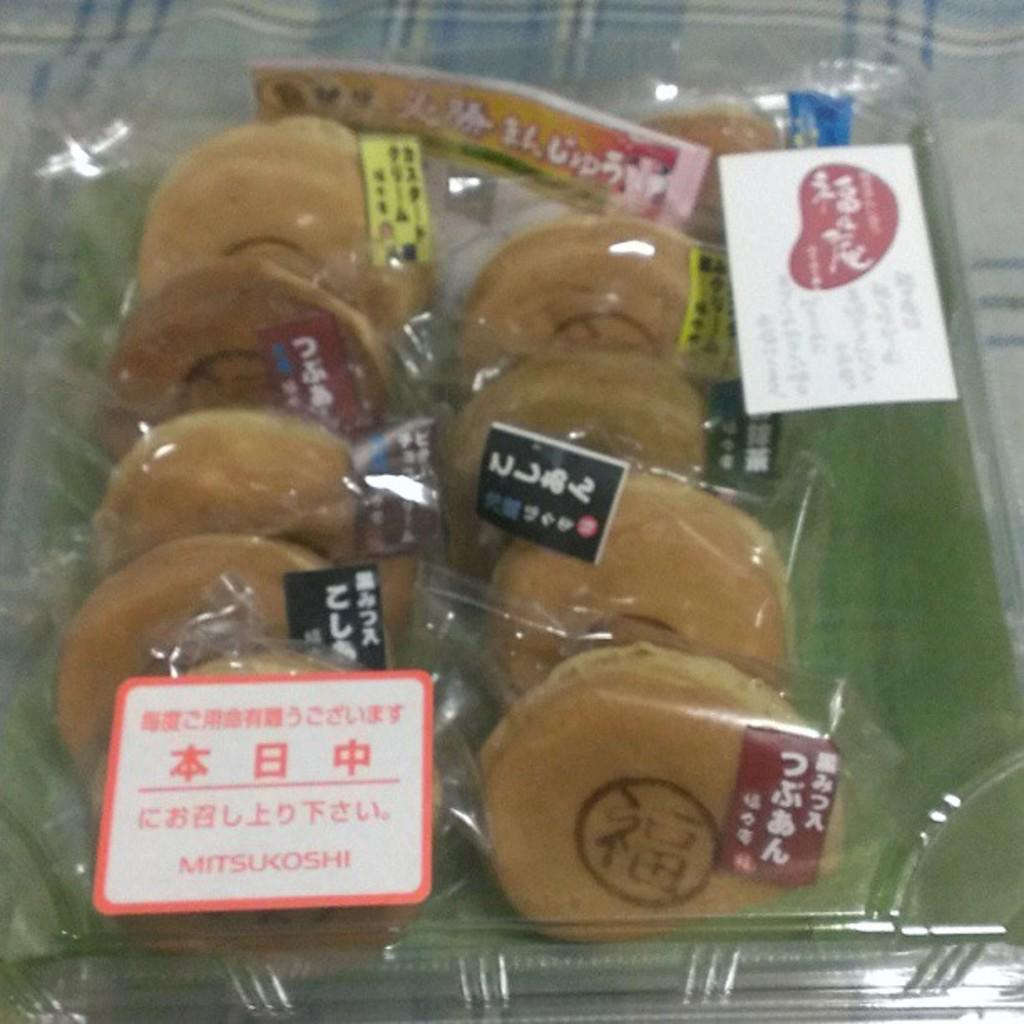What type of items can be seen in the image? There are food items in the image. How are the food items contained in the image? The food items are in a cover. Where is the cover located in the image? The cover is in a box. Are there any additional decorations or markings on the cover? Yes, there are stickers attached to the cover. What type of cable is connected to the food items in the image? There is no cable connected to the food items in the image. Can you tell me how many times your mom visited the food items in the image? There is no information about your mom or any visits in the image. 